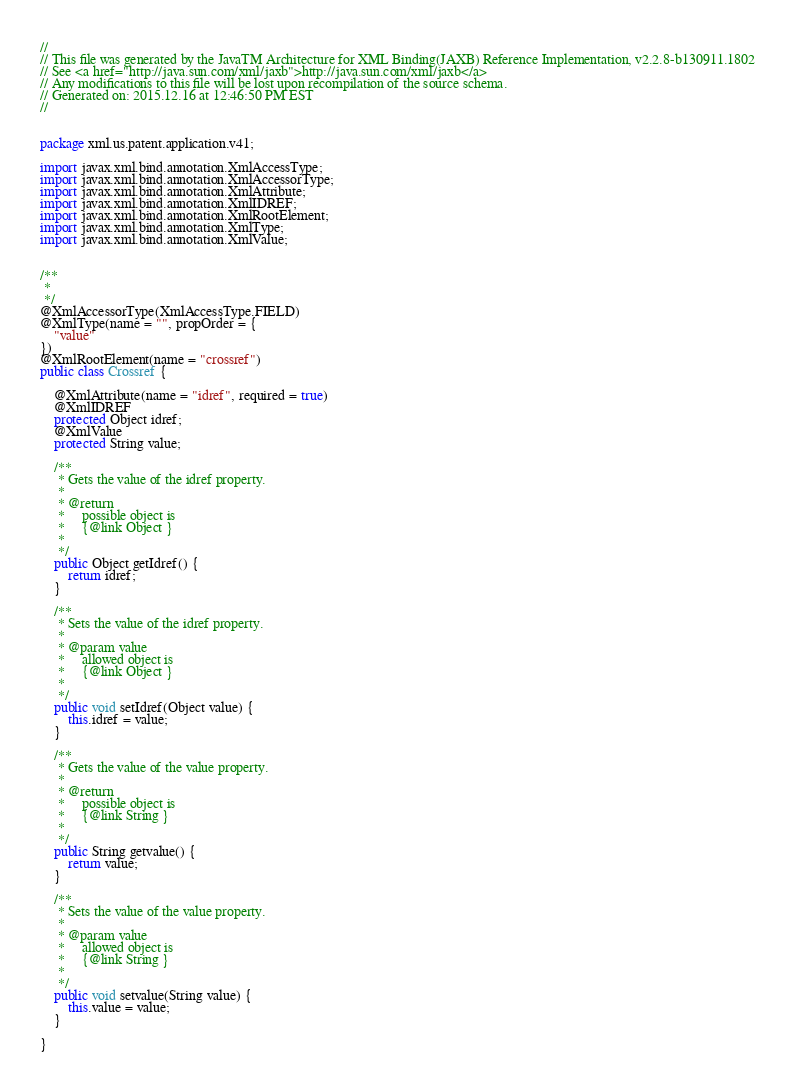Convert code to text. <code><loc_0><loc_0><loc_500><loc_500><_Java_>//
// This file was generated by the JavaTM Architecture for XML Binding(JAXB) Reference Implementation, v2.2.8-b130911.1802 
// See <a href="http://java.sun.com/xml/jaxb">http://java.sun.com/xml/jaxb</a> 
// Any modifications to this file will be lost upon recompilation of the source schema. 
// Generated on: 2015.12.16 at 12:46:50 PM EST 
//


package xml.us.patent.application.v41;

import javax.xml.bind.annotation.XmlAccessType;
import javax.xml.bind.annotation.XmlAccessorType;
import javax.xml.bind.annotation.XmlAttribute;
import javax.xml.bind.annotation.XmlIDREF;
import javax.xml.bind.annotation.XmlRootElement;
import javax.xml.bind.annotation.XmlType;
import javax.xml.bind.annotation.XmlValue;


/**
 * 
 */
@XmlAccessorType(XmlAccessType.FIELD)
@XmlType(name = "", propOrder = {
    "value"
})
@XmlRootElement(name = "crossref")
public class Crossref {

    @XmlAttribute(name = "idref", required = true)
    @XmlIDREF
    protected Object idref;
    @XmlValue
    protected String value;

    /**
     * Gets the value of the idref property.
     * 
     * @return
     *     possible object is
     *     {@link Object }
     *     
     */
    public Object getIdref() {
        return idref;
    }

    /**
     * Sets the value of the idref property.
     * 
     * @param value
     *     allowed object is
     *     {@link Object }
     *     
     */
    public void setIdref(Object value) {
        this.idref = value;
    }

    /**
     * Gets the value of the value property.
     * 
     * @return
     *     possible object is
     *     {@link String }
     *     
     */
    public String getvalue() {
        return value;
    }

    /**
     * Sets the value of the value property.
     * 
     * @param value
     *     allowed object is
     *     {@link String }
     *     
     */
    public void setvalue(String value) {
        this.value = value;
    }

}
</code> 